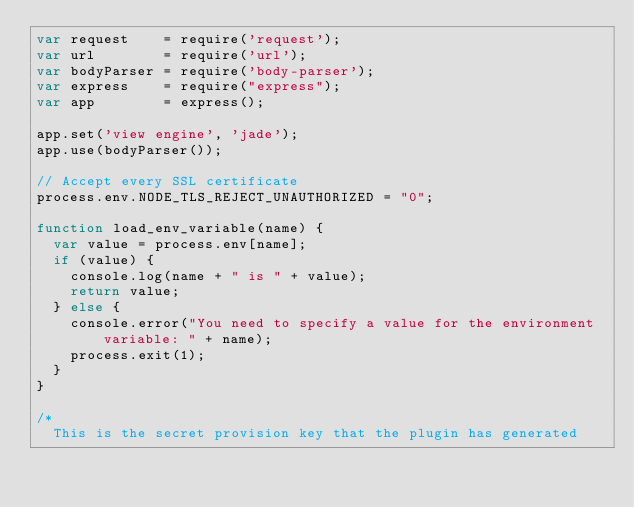<code> <loc_0><loc_0><loc_500><loc_500><_JavaScript_>var request    = require('request');
var url        = require('url');
var bodyParser = require('body-parser');
var express    = require("express");
var app        = express();

app.set('view engine', 'jade');
app.use(bodyParser());

// Accept every SSL certificate
process.env.NODE_TLS_REJECT_UNAUTHORIZED = "0";

function load_env_variable(name) {
  var value = process.env[name];
  if (value) {
    console.log(name + " is " + value);
    return value;
  } else {
    console.error("You need to specify a value for the environment variable: " + name);
    process.exit(1);
  }
}

/*
  This is the secret provision key that the plugin has generated</code> 